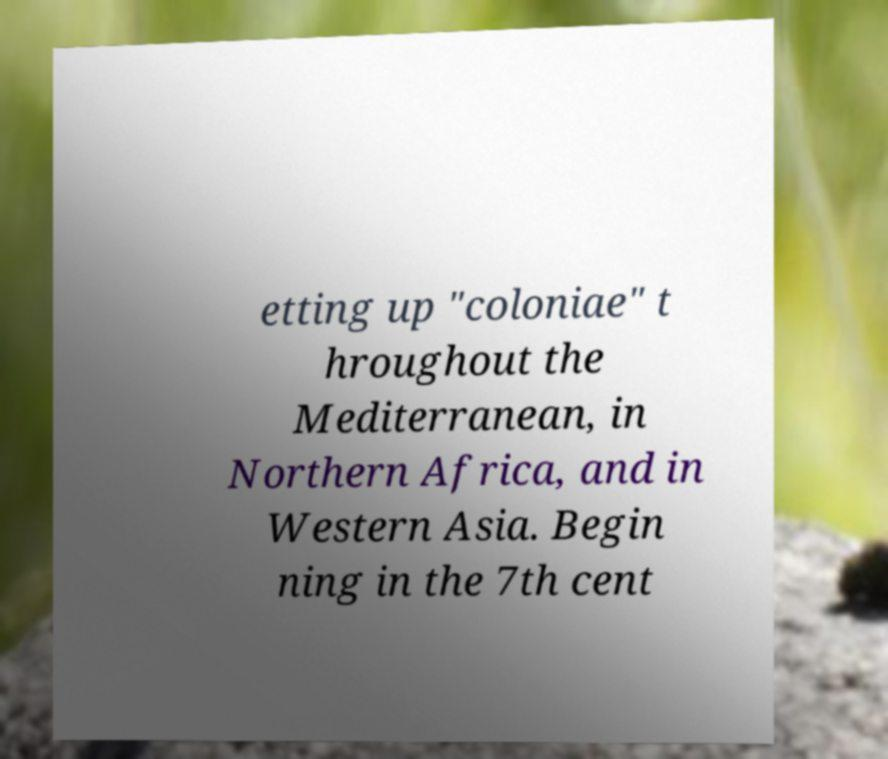Could you assist in decoding the text presented in this image and type it out clearly? etting up "coloniae" t hroughout the Mediterranean, in Northern Africa, and in Western Asia. Begin ning in the 7th cent 